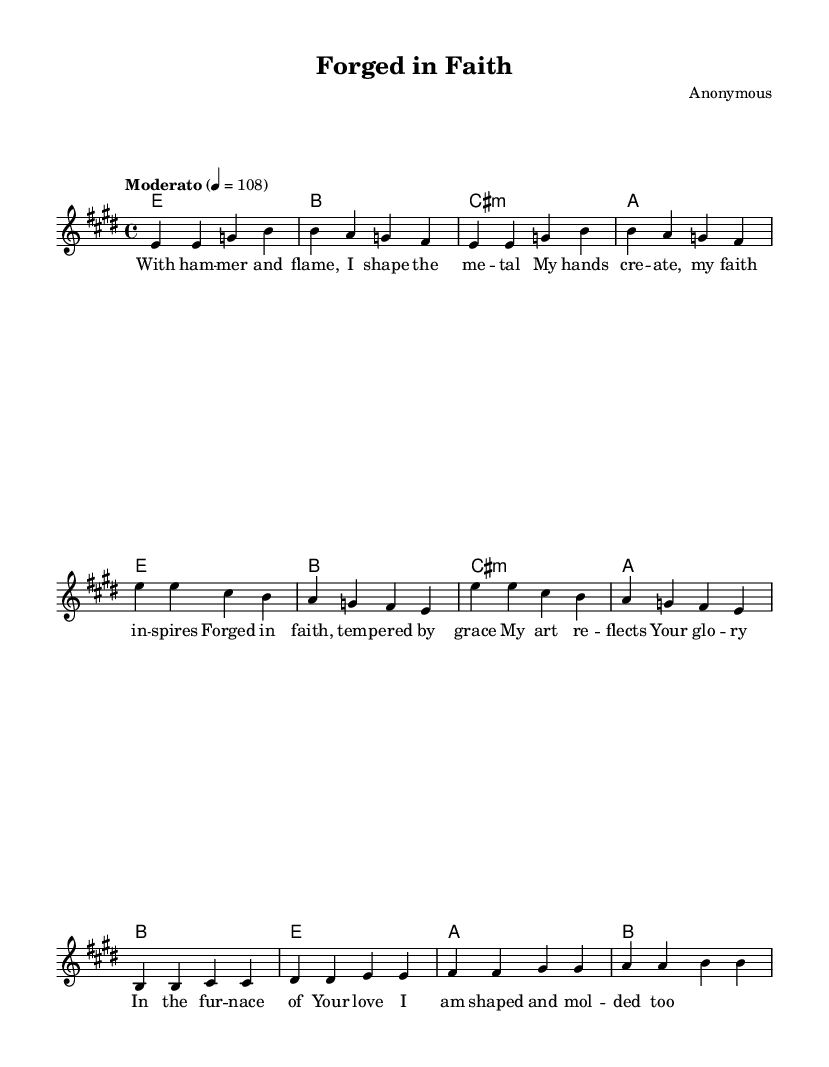What is the key signature of this music? The key signature is E major, which has four sharps (F#, C#, G#, and D#). This can be deduced from the beginning of the score, where the key is indicated.
Answer: E major What is the time signature of this piece? The time signature is 4/4, indicating four beats per measure. This is found at the beginning of the staff, showing the rhythm structure of the piece.
Answer: 4/4 What is the tempo marking given for the music? The tempo marking indicates "Moderato" at a speed of 108 beats per minute. This information is available in the tempo directive seen at the beginning of the score.
Answer: Moderato, 108 How many sections are there in the piece? The piece contains three sections: Verse, Chorus, and Bridge. By examining the layout of the score, we can identify these distinct parts clearly labeled in the music structure.
Answer: Three What is the name of the piece? The title of the piece is "Forged in Faith," which is indicated prominently at the top of the score. This provides immediate identification of the composition.
Answer: Forged in Faith Which musical modes are primarily used in the harmony? The harmony primarily utilizes major and minor chords, specifically E major, B major, C# minor, and A major. Analyzing the chord symbols written above the staff shows the relationship between the chords.
Answer: Major and minor What themes does the lyrics convey? The lyrics convey themes of craftsmanship, faith, and dedication to God, reflecting the idea of forging metal as a metaphor for spiritual growth. This can be interpreted by reading the lyrical content that emphasizes creation through divine inspiration.
Answer: Craftsmanship and faith 